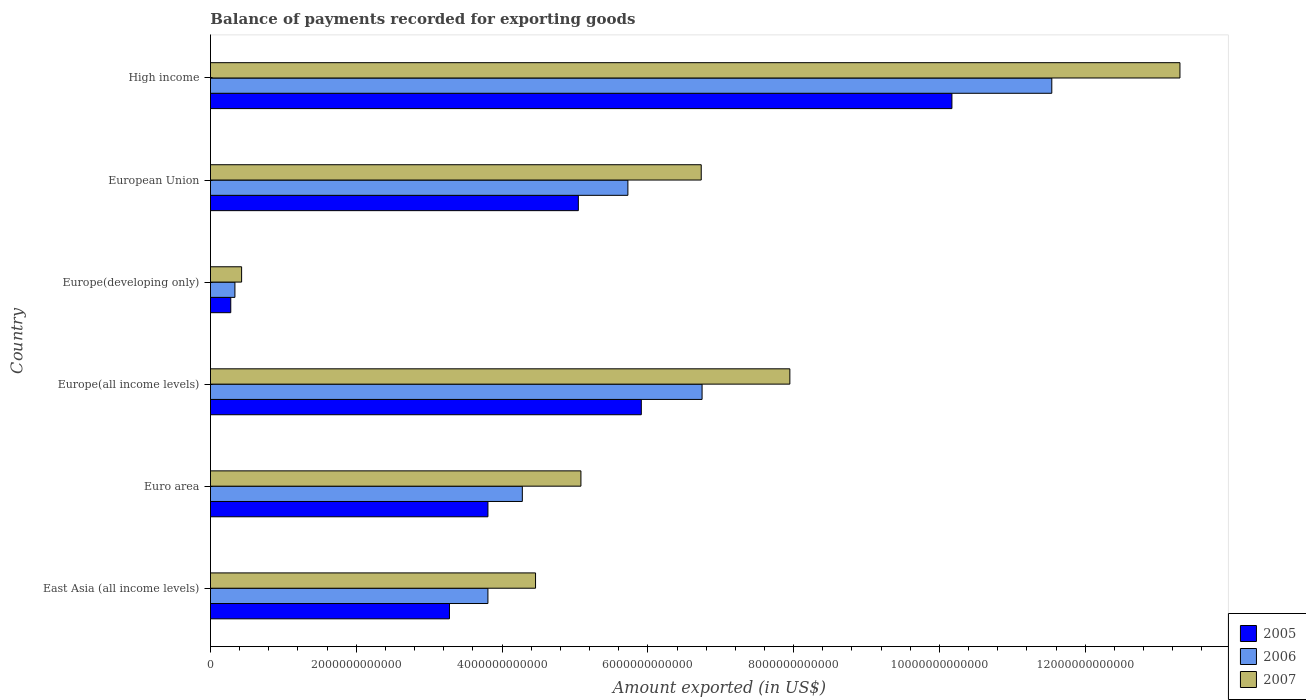How many different coloured bars are there?
Offer a very short reply. 3. How many groups of bars are there?
Ensure brevity in your answer.  6. Are the number of bars per tick equal to the number of legend labels?
Offer a very short reply. Yes. Are the number of bars on each tick of the Y-axis equal?
Give a very brief answer. Yes. How many bars are there on the 4th tick from the bottom?
Offer a very short reply. 3. What is the label of the 5th group of bars from the top?
Give a very brief answer. Euro area. What is the amount exported in 2005 in Europe(all income levels)?
Your answer should be very brief. 5.91e+12. Across all countries, what is the maximum amount exported in 2007?
Make the answer very short. 1.33e+13. Across all countries, what is the minimum amount exported in 2006?
Your response must be concise. 3.35e+11. In which country was the amount exported in 2005 minimum?
Give a very brief answer. Europe(developing only). What is the total amount exported in 2007 in the graph?
Your answer should be very brief. 3.79e+13. What is the difference between the amount exported in 2005 in Europe(all income levels) and that in Europe(developing only)?
Your response must be concise. 5.63e+12. What is the difference between the amount exported in 2005 in East Asia (all income levels) and the amount exported in 2006 in High income?
Keep it short and to the point. -8.26e+12. What is the average amount exported in 2005 per country?
Make the answer very short. 4.75e+12. What is the difference between the amount exported in 2005 and amount exported in 2006 in Euro area?
Make the answer very short. -4.72e+11. What is the ratio of the amount exported in 2006 in East Asia (all income levels) to that in Europe(all income levels)?
Offer a very short reply. 0.56. Is the amount exported in 2006 in Europe(developing only) less than that in European Union?
Provide a succinct answer. Yes. What is the difference between the highest and the second highest amount exported in 2006?
Keep it short and to the point. 4.80e+12. What is the difference between the highest and the lowest amount exported in 2007?
Offer a terse response. 1.29e+13. In how many countries, is the amount exported in 2005 greater than the average amount exported in 2005 taken over all countries?
Your answer should be very brief. 3. Is the sum of the amount exported in 2007 in East Asia (all income levels) and Europe(all income levels) greater than the maximum amount exported in 2006 across all countries?
Provide a short and direct response. Yes. What does the 1st bar from the top in Europe(developing only) represents?
Provide a succinct answer. 2007. What does the 1st bar from the bottom in Europe(all income levels) represents?
Offer a terse response. 2005. Is it the case that in every country, the sum of the amount exported in 2007 and amount exported in 2006 is greater than the amount exported in 2005?
Provide a short and direct response. Yes. How many bars are there?
Your answer should be compact. 18. What is the difference between two consecutive major ticks on the X-axis?
Keep it short and to the point. 2.00e+12. Are the values on the major ticks of X-axis written in scientific E-notation?
Offer a terse response. No. Does the graph contain any zero values?
Your answer should be compact. No. Does the graph contain grids?
Offer a very short reply. No. Where does the legend appear in the graph?
Your answer should be compact. Bottom right. How are the legend labels stacked?
Provide a short and direct response. Vertical. What is the title of the graph?
Offer a terse response. Balance of payments recorded for exporting goods. Does "2001" appear as one of the legend labels in the graph?
Your response must be concise. No. What is the label or title of the X-axis?
Your answer should be compact. Amount exported (in US$). What is the label or title of the Y-axis?
Keep it short and to the point. Country. What is the Amount exported (in US$) of 2005 in East Asia (all income levels)?
Your answer should be compact. 3.28e+12. What is the Amount exported (in US$) of 2006 in East Asia (all income levels)?
Offer a terse response. 3.81e+12. What is the Amount exported (in US$) of 2007 in East Asia (all income levels)?
Provide a succinct answer. 4.46e+12. What is the Amount exported (in US$) in 2005 in Euro area?
Provide a short and direct response. 3.81e+12. What is the Amount exported (in US$) of 2006 in Euro area?
Provide a short and direct response. 4.28e+12. What is the Amount exported (in US$) in 2007 in Euro area?
Provide a succinct answer. 5.08e+12. What is the Amount exported (in US$) of 2005 in Europe(all income levels)?
Give a very brief answer. 5.91e+12. What is the Amount exported (in US$) in 2006 in Europe(all income levels)?
Offer a very short reply. 6.74e+12. What is the Amount exported (in US$) in 2007 in Europe(all income levels)?
Your response must be concise. 7.95e+12. What is the Amount exported (in US$) in 2005 in Europe(developing only)?
Your answer should be compact. 2.78e+11. What is the Amount exported (in US$) of 2006 in Europe(developing only)?
Offer a terse response. 3.35e+11. What is the Amount exported (in US$) in 2007 in Europe(developing only)?
Offer a very short reply. 4.27e+11. What is the Amount exported (in US$) in 2005 in European Union?
Make the answer very short. 5.05e+12. What is the Amount exported (in US$) of 2006 in European Union?
Offer a terse response. 5.73e+12. What is the Amount exported (in US$) of 2007 in European Union?
Provide a succinct answer. 6.73e+12. What is the Amount exported (in US$) of 2005 in High income?
Your answer should be very brief. 1.02e+13. What is the Amount exported (in US$) of 2006 in High income?
Offer a terse response. 1.15e+13. What is the Amount exported (in US$) in 2007 in High income?
Your answer should be compact. 1.33e+13. Across all countries, what is the maximum Amount exported (in US$) of 2005?
Make the answer very short. 1.02e+13. Across all countries, what is the maximum Amount exported (in US$) in 2006?
Provide a short and direct response. 1.15e+13. Across all countries, what is the maximum Amount exported (in US$) of 2007?
Your answer should be compact. 1.33e+13. Across all countries, what is the minimum Amount exported (in US$) in 2005?
Give a very brief answer. 2.78e+11. Across all countries, what is the minimum Amount exported (in US$) in 2006?
Offer a terse response. 3.35e+11. Across all countries, what is the minimum Amount exported (in US$) of 2007?
Offer a terse response. 4.27e+11. What is the total Amount exported (in US$) of 2005 in the graph?
Your answer should be very brief. 2.85e+13. What is the total Amount exported (in US$) in 2006 in the graph?
Provide a succinct answer. 3.24e+13. What is the total Amount exported (in US$) in 2007 in the graph?
Provide a short and direct response. 3.79e+13. What is the difference between the Amount exported (in US$) in 2005 in East Asia (all income levels) and that in Euro area?
Provide a short and direct response. -5.28e+11. What is the difference between the Amount exported (in US$) of 2006 in East Asia (all income levels) and that in Euro area?
Offer a terse response. -4.72e+11. What is the difference between the Amount exported (in US$) in 2007 in East Asia (all income levels) and that in Euro area?
Keep it short and to the point. -6.22e+11. What is the difference between the Amount exported (in US$) of 2005 in East Asia (all income levels) and that in Europe(all income levels)?
Your answer should be very brief. -2.63e+12. What is the difference between the Amount exported (in US$) of 2006 in East Asia (all income levels) and that in Europe(all income levels)?
Provide a succinct answer. -2.94e+12. What is the difference between the Amount exported (in US$) in 2007 in East Asia (all income levels) and that in Europe(all income levels)?
Offer a very short reply. -3.49e+12. What is the difference between the Amount exported (in US$) in 2005 in East Asia (all income levels) and that in Europe(developing only)?
Provide a succinct answer. 3.00e+12. What is the difference between the Amount exported (in US$) of 2006 in East Asia (all income levels) and that in Europe(developing only)?
Provide a succinct answer. 3.47e+12. What is the difference between the Amount exported (in US$) in 2007 in East Asia (all income levels) and that in Europe(developing only)?
Offer a terse response. 4.03e+12. What is the difference between the Amount exported (in US$) in 2005 in East Asia (all income levels) and that in European Union?
Keep it short and to the point. -1.77e+12. What is the difference between the Amount exported (in US$) of 2006 in East Asia (all income levels) and that in European Union?
Provide a succinct answer. -1.92e+12. What is the difference between the Amount exported (in US$) in 2007 in East Asia (all income levels) and that in European Union?
Your response must be concise. -2.27e+12. What is the difference between the Amount exported (in US$) in 2005 in East Asia (all income levels) and that in High income?
Your answer should be very brief. -6.89e+12. What is the difference between the Amount exported (in US$) of 2006 in East Asia (all income levels) and that in High income?
Ensure brevity in your answer.  -7.74e+12. What is the difference between the Amount exported (in US$) in 2007 in East Asia (all income levels) and that in High income?
Provide a short and direct response. -8.84e+12. What is the difference between the Amount exported (in US$) in 2005 in Euro area and that in Europe(all income levels)?
Ensure brevity in your answer.  -2.10e+12. What is the difference between the Amount exported (in US$) in 2006 in Euro area and that in Europe(all income levels)?
Provide a short and direct response. -2.47e+12. What is the difference between the Amount exported (in US$) in 2007 in Euro area and that in Europe(all income levels)?
Offer a terse response. -2.87e+12. What is the difference between the Amount exported (in US$) of 2005 in Euro area and that in Europe(developing only)?
Your response must be concise. 3.53e+12. What is the difference between the Amount exported (in US$) of 2006 in Euro area and that in Europe(developing only)?
Ensure brevity in your answer.  3.94e+12. What is the difference between the Amount exported (in US$) in 2007 in Euro area and that in Europe(developing only)?
Ensure brevity in your answer.  4.65e+12. What is the difference between the Amount exported (in US$) in 2005 in Euro area and that in European Union?
Give a very brief answer. -1.24e+12. What is the difference between the Amount exported (in US$) in 2006 in Euro area and that in European Union?
Ensure brevity in your answer.  -1.45e+12. What is the difference between the Amount exported (in US$) in 2007 in Euro area and that in European Union?
Offer a very short reply. -1.65e+12. What is the difference between the Amount exported (in US$) of 2005 in Euro area and that in High income?
Ensure brevity in your answer.  -6.37e+12. What is the difference between the Amount exported (in US$) of 2006 in Euro area and that in High income?
Give a very brief answer. -7.26e+12. What is the difference between the Amount exported (in US$) in 2007 in Euro area and that in High income?
Your response must be concise. -8.22e+12. What is the difference between the Amount exported (in US$) of 2005 in Europe(all income levels) and that in Europe(developing only)?
Make the answer very short. 5.63e+12. What is the difference between the Amount exported (in US$) in 2006 in Europe(all income levels) and that in Europe(developing only)?
Your answer should be very brief. 6.41e+12. What is the difference between the Amount exported (in US$) of 2007 in Europe(all income levels) and that in Europe(developing only)?
Your response must be concise. 7.52e+12. What is the difference between the Amount exported (in US$) of 2005 in Europe(all income levels) and that in European Union?
Provide a short and direct response. 8.64e+11. What is the difference between the Amount exported (in US$) in 2006 in Europe(all income levels) and that in European Union?
Your answer should be compact. 1.02e+12. What is the difference between the Amount exported (in US$) in 2007 in Europe(all income levels) and that in European Union?
Offer a terse response. 1.22e+12. What is the difference between the Amount exported (in US$) in 2005 in Europe(all income levels) and that in High income?
Offer a terse response. -4.26e+12. What is the difference between the Amount exported (in US$) in 2006 in Europe(all income levels) and that in High income?
Provide a short and direct response. -4.80e+12. What is the difference between the Amount exported (in US$) in 2007 in Europe(all income levels) and that in High income?
Your response must be concise. -5.35e+12. What is the difference between the Amount exported (in US$) in 2005 in Europe(developing only) and that in European Union?
Make the answer very short. -4.77e+12. What is the difference between the Amount exported (in US$) of 2006 in Europe(developing only) and that in European Union?
Make the answer very short. -5.39e+12. What is the difference between the Amount exported (in US$) in 2007 in Europe(developing only) and that in European Union?
Your answer should be very brief. -6.31e+12. What is the difference between the Amount exported (in US$) in 2005 in Europe(developing only) and that in High income?
Provide a short and direct response. -9.89e+12. What is the difference between the Amount exported (in US$) in 2006 in Europe(developing only) and that in High income?
Ensure brevity in your answer.  -1.12e+13. What is the difference between the Amount exported (in US$) in 2007 in Europe(developing only) and that in High income?
Ensure brevity in your answer.  -1.29e+13. What is the difference between the Amount exported (in US$) of 2005 in European Union and that in High income?
Ensure brevity in your answer.  -5.13e+12. What is the difference between the Amount exported (in US$) of 2006 in European Union and that in High income?
Your response must be concise. -5.82e+12. What is the difference between the Amount exported (in US$) of 2007 in European Union and that in High income?
Ensure brevity in your answer.  -6.57e+12. What is the difference between the Amount exported (in US$) of 2005 in East Asia (all income levels) and the Amount exported (in US$) of 2006 in Euro area?
Keep it short and to the point. -1.00e+12. What is the difference between the Amount exported (in US$) of 2005 in East Asia (all income levels) and the Amount exported (in US$) of 2007 in Euro area?
Provide a succinct answer. -1.80e+12. What is the difference between the Amount exported (in US$) of 2006 in East Asia (all income levels) and the Amount exported (in US$) of 2007 in Euro area?
Give a very brief answer. -1.28e+12. What is the difference between the Amount exported (in US$) in 2005 in East Asia (all income levels) and the Amount exported (in US$) in 2006 in Europe(all income levels)?
Provide a short and direct response. -3.47e+12. What is the difference between the Amount exported (in US$) of 2005 in East Asia (all income levels) and the Amount exported (in US$) of 2007 in Europe(all income levels)?
Provide a succinct answer. -4.67e+12. What is the difference between the Amount exported (in US$) of 2006 in East Asia (all income levels) and the Amount exported (in US$) of 2007 in Europe(all income levels)?
Your response must be concise. -4.14e+12. What is the difference between the Amount exported (in US$) of 2005 in East Asia (all income levels) and the Amount exported (in US$) of 2006 in Europe(developing only)?
Provide a succinct answer. 2.94e+12. What is the difference between the Amount exported (in US$) of 2005 in East Asia (all income levels) and the Amount exported (in US$) of 2007 in Europe(developing only)?
Provide a short and direct response. 2.85e+12. What is the difference between the Amount exported (in US$) in 2006 in East Asia (all income levels) and the Amount exported (in US$) in 2007 in Europe(developing only)?
Make the answer very short. 3.38e+12. What is the difference between the Amount exported (in US$) in 2005 in East Asia (all income levels) and the Amount exported (in US$) in 2006 in European Union?
Make the answer very short. -2.45e+12. What is the difference between the Amount exported (in US$) in 2005 in East Asia (all income levels) and the Amount exported (in US$) in 2007 in European Union?
Give a very brief answer. -3.45e+12. What is the difference between the Amount exported (in US$) of 2006 in East Asia (all income levels) and the Amount exported (in US$) of 2007 in European Union?
Your response must be concise. -2.93e+12. What is the difference between the Amount exported (in US$) in 2005 in East Asia (all income levels) and the Amount exported (in US$) in 2006 in High income?
Your answer should be very brief. -8.26e+12. What is the difference between the Amount exported (in US$) of 2005 in East Asia (all income levels) and the Amount exported (in US$) of 2007 in High income?
Provide a succinct answer. -1.00e+13. What is the difference between the Amount exported (in US$) of 2006 in East Asia (all income levels) and the Amount exported (in US$) of 2007 in High income?
Provide a succinct answer. -9.49e+12. What is the difference between the Amount exported (in US$) in 2005 in Euro area and the Amount exported (in US$) in 2006 in Europe(all income levels)?
Your answer should be compact. -2.94e+12. What is the difference between the Amount exported (in US$) of 2005 in Euro area and the Amount exported (in US$) of 2007 in Europe(all income levels)?
Offer a terse response. -4.14e+12. What is the difference between the Amount exported (in US$) in 2006 in Euro area and the Amount exported (in US$) in 2007 in Europe(all income levels)?
Your answer should be compact. -3.67e+12. What is the difference between the Amount exported (in US$) in 2005 in Euro area and the Amount exported (in US$) in 2006 in Europe(developing only)?
Keep it short and to the point. 3.47e+12. What is the difference between the Amount exported (in US$) of 2005 in Euro area and the Amount exported (in US$) of 2007 in Europe(developing only)?
Offer a very short reply. 3.38e+12. What is the difference between the Amount exported (in US$) of 2006 in Euro area and the Amount exported (in US$) of 2007 in Europe(developing only)?
Provide a succinct answer. 3.85e+12. What is the difference between the Amount exported (in US$) in 2005 in Euro area and the Amount exported (in US$) in 2006 in European Union?
Your answer should be very brief. -1.92e+12. What is the difference between the Amount exported (in US$) in 2005 in Euro area and the Amount exported (in US$) in 2007 in European Union?
Ensure brevity in your answer.  -2.93e+12. What is the difference between the Amount exported (in US$) in 2006 in Euro area and the Amount exported (in US$) in 2007 in European Union?
Ensure brevity in your answer.  -2.45e+12. What is the difference between the Amount exported (in US$) of 2005 in Euro area and the Amount exported (in US$) of 2006 in High income?
Ensure brevity in your answer.  -7.74e+12. What is the difference between the Amount exported (in US$) of 2005 in Euro area and the Amount exported (in US$) of 2007 in High income?
Your answer should be very brief. -9.49e+12. What is the difference between the Amount exported (in US$) in 2006 in Euro area and the Amount exported (in US$) in 2007 in High income?
Keep it short and to the point. -9.02e+12. What is the difference between the Amount exported (in US$) of 2005 in Europe(all income levels) and the Amount exported (in US$) of 2006 in Europe(developing only)?
Provide a succinct answer. 5.58e+12. What is the difference between the Amount exported (in US$) in 2005 in Europe(all income levels) and the Amount exported (in US$) in 2007 in Europe(developing only)?
Your answer should be compact. 5.48e+12. What is the difference between the Amount exported (in US$) of 2006 in Europe(all income levels) and the Amount exported (in US$) of 2007 in Europe(developing only)?
Give a very brief answer. 6.32e+12. What is the difference between the Amount exported (in US$) of 2005 in Europe(all income levels) and the Amount exported (in US$) of 2006 in European Union?
Provide a short and direct response. 1.84e+11. What is the difference between the Amount exported (in US$) of 2005 in Europe(all income levels) and the Amount exported (in US$) of 2007 in European Union?
Provide a succinct answer. -8.22e+11. What is the difference between the Amount exported (in US$) of 2006 in Europe(all income levels) and the Amount exported (in US$) of 2007 in European Union?
Give a very brief answer. 1.16e+1. What is the difference between the Amount exported (in US$) of 2005 in Europe(all income levels) and the Amount exported (in US$) of 2006 in High income?
Your answer should be very brief. -5.63e+12. What is the difference between the Amount exported (in US$) in 2005 in Europe(all income levels) and the Amount exported (in US$) in 2007 in High income?
Your response must be concise. -7.39e+12. What is the difference between the Amount exported (in US$) of 2006 in Europe(all income levels) and the Amount exported (in US$) of 2007 in High income?
Offer a terse response. -6.56e+12. What is the difference between the Amount exported (in US$) in 2005 in Europe(developing only) and the Amount exported (in US$) in 2006 in European Union?
Your response must be concise. -5.45e+12. What is the difference between the Amount exported (in US$) in 2005 in Europe(developing only) and the Amount exported (in US$) in 2007 in European Union?
Your response must be concise. -6.45e+12. What is the difference between the Amount exported (in US$) in 2006 in Europe(developing only) and the Amount exported (in US$) in 2007 in European Union?
Your response must be concise. -6.40e+12. What is the difference between the Amount exported (in US$) in 2005 in Europe(developing only) and the Amount exported (in US$) in 2006 in High income?
Give a very brief answer. -1.13e+13. What is the difference between the Amount exported (in US$) in 2005 in Europe(developing only) and the Amount exported (in US$) in 2007 in High income?
Ensure brevity in your answer.  -1.30e+13. What is the difference between the Amount exported (in US$) in 2006 in Europe(developing only) and the Amount exported (in US$) in 2007 in High income?
Your answer should be compact. -1.30e+13. What is the difference between the Amount exported (in US$) of 2005 in European Union and the Amount exported (in US$) of 2006 in High income?
Offer a terse response. -6.50e+12. What is the difference between the Amount exported (in US$) of 2005 in European Union and the Amount exported (in US$) of 2007 in High income?
Ensure brevity in your answer.  -8.25e+12. What is the difference between the Amount exported (in US$) of 2006 in European Union and the Amount exported (in US$) of 2007 in High income?
Provide a short and direct response. -7.57e+12. What is the average Amount exported (in US$) in 2005 per country?
Make the answer very short. 4.75e+12. What is the average Amount exported (in US$) of 2006 per country?
Your answer should be very brief. 5.41e+12. What is the average Amount exported (in US$) of 2007 per country?
Ensure brevity in your answer.  6.32e+12. What is the difference between the Amount exported (in US$) in 2005 and Amount exported (in US$) in 2006 in East Asia (all income levels)?
Provide a succinct answer. -5.28e+11. What is the difference between the Amount exported (in US$) in 2005 and Amount exported (in US$) in 2007 in East Asia (all income levels)?
Provide a short and direct response. -1.18e+12. What is the difference between the Amount exported (in US$) of 2006 and Amount exported (in US$) of 2007 in East Asia (all income levels)?
Offer a very short reply. -6.53e+11. What is the difference between the Amount exported (in US$) of 2005 and Amount exported (in US$) of 2006 in Euro area?
Offer a terse response. -4.72e+11. What is the difference between the Amount exported (in US$) in 2005 and Amount exported (in US$) in 2007 in Euro area?
Your response must be concise. -1.28e+12. What is the difference between the Amount exported (in US$) in 2006 and Amount exported (in US$) in 2007 in Euro area?
Your response must be concise. -8.04e+11. What is the difference between the Amount exported (in US$) of 2005 and Amount exported (in US$) of 2006 in Europe(all income levels)?
Make the answer very short. -8.34e+11. What is the difference between the Amount exported (in US$) of 2005 and Amount exported (in US$) of 2007 in Europe(all income levels)?
Keep it short and to the point. -2.04e+12. What is the difference between the Amount exported (in US$) in 2006 and Amount exported (in US$) in 2007 in Europe(all income levels)?
Offer a very short reply. -1.20e+12. What is the difference between the Amount exported (in US$) of 2005 and Amount exported (in US$) of 2006 in Europe(developing only)?
Your response must be concise. -5.70e+1. What is the difference between the Amount exported (in US$) in 2005 and Amount exported (in US$) in 2007 in Europe(developing only)?
Provide a short and direct response. -1.49e+11. What is the difference between the Amount exported (in US$) in 2006 and Amount exported (in US$) in 2007 in Europe(developing only)?
Offer a terse response. -9.17e+1. What is the difference between the Amount exported (in US$) in 2005 and Amount exported (in US$) in 2006 in European Union?
Your answer should be very brief. -6.80e+11. What is the difference between the Amount exported (in US$) of 2005 and Amount exported (in US$) of 2007 in European Union?
Your answer should be compact. -1.69e+12. What is the difference between the Amount exported (in US$) in 2006 and Amount exported (in US$) in 2007 in European Union?
Your response must be concise. -1.01e+12. What is the difference between the Amount exported (in US$) of 2005 and Amount exported (in US$) of 2006 in High income?
Your answer should be very brief. -1.37e+12. What is the difference between the Amount exported (in US$) of 2005 and Amount exported (in US$) of 2007 in High income?
Your answer should be compact. -3.13e+12. What is the difference between the Amount exported (in US$) in 2006 and Amount exported (in US$) in 2007 in High income?
Ensure brevity in your answer.  -1.76e+12. What is the ratio of the Amount exported (in US$) of 2005 in East Asia (all income levels) to that in Euro area?
Your answer should be compact. 0.86. What is the ratio of the Amount exported (in US$) in 2006 in East Asia (all income levels) to that in Euro area?
Provide a short and direct response. 0.89. What is the ratio of the Amount exported (in US$) in 2007 in East Asia (all income levels) to that in Euro area?
Provide a short and direct response. 0.88. What is the ratio of the Amount exported (in US$) of 2005 in East Asia (all income levels) to that in Europe(all income levels)?
Your answer should be compact. 0.55. What is the ratio of the Amount exported (in US$) in 2006 in East Asia (all income levels) to that in Europe(all income levels)?
Offer a terse response. 0.56. What is the ratio of the Amount exported (in US$) in 2007 in East Asia (all income levels) to that in Europe(all income levels)?
Ensure brevity in your answer.  0.56. What is the ratio of the Amount exported (in US$) in 2005 in East Asia (all income levels) to that in Europe(developing only)?
Keep it short and to the point. 11.78. What is the ratio of the Amount exported (in US$) of 2006 in East Asia (all income levels) to that in Europe(developing only)?
Offer a very short reply. 11.35. What is the ratio of the Amount exported (in US$) of 2007 in East Asia (all income levels) to that in Europe(developing only)?
Provide a succinct answer. 10.44. What is the ratio of the Amount exported (in US$) in 2005 in East Asia (all income levels) to that in European Union?
Your response must be concise. 0.65. What is the ratio of the Amount exported (in US$) of 2006 in East Asia (all income levels) to that in European Union?
Keep it short and to the point. 0.66. What is the ratio of the Amount exported (in US$) in 2007 in East Asia (all income levels) to that in European Union?
Ensure brevity in your answer.  0.66. What is the ratio of the Amount exported (in US$) in 2005 in East Asia (all income levels) to that in High income?
Provide a succinct answer. 0.32. What is the ratio of the Amount exported (in US$) in 2006 in East Asia (all income levels) to that in High income?
Offer a terse response. 0.33. What is the ratio of the Amount exported (in US$) in 2007 in East Asia (all income levels) to that in High income?
Keep it short and to the point. 0.34. What is the ratio of the Amount exported (in US$) in 2005 in Euro area to that in Europe(all income levels)?
Keep it short and to the point. 0.64. What is the ratio of the Amount exported (in US$) in 2006 in Euro area to that in Europe(all income levels)?
Offer a terse response. 0.63. What is the ratio of the Amount exported (in US$) in 2007 in Euro area to that in Europe(all income levels)?
Offer a terse response. 0.64. What is the ratio of the Amount exported (in US$) of 2005 in Euro area to that in Europe(developing only)?
Make the answer very short. 13.67. What is the ratio of the Amount exported (in US$) of 2006 in Euro area to that in Europe(developing only)?
Provide a succinct answer. 12.76. What is the ratio of the Amount exported (in US$) of 2007 in Euro area to that in Europe(developing only)?
Offer a very short reply. 11.9. What is the ratio of the Amount exported (in US$) in 2005 in Euro area to that in European Union?
Give a very brief answer. 0.75. What is the ratio of the Amount exported (in US$) in 2006 in Euro area to that in European Union?
Provide a succinct answer. 0.75. What is the ratio of the Amount exported (in US$) of 2007 in Euro area to that in European Union?
Your answer should be compact. 0.75. What is the ratio of the Amount exported (in US$) in 2005 in Euro area to that in High income?
Provide a short and direct response. 0.37. What is the ratio of the Amount exported (in US$) of 2006 in Euro area to that in High income?
Your answer should be very brief. 0.37. What is the ratio of the Amount exported (in US$) of 2007 in Euro area to that in High income?
Provide a succinct answer. 0.38. What is the ratio of the Amount exported (in US$) of 2005 in Europe(all income levels) to that in Europe(developing only)?
Your answer should be very brief. 21.23. What is the ratio of the Amount exported (in US$) in 2006 in Europe(all income levels) to that in Europe(developing only)?
Provide a succinct answer. 20.11. What is the ratio of the Amount exported (in US$) in 2007 in Europe(all income levels) to that in Europe(developing only)?
Your answer should be very brief. 18.61. What is the ratio of the Amount exported (in US$) of 2005 in Europe(all income levels) to that in European Union?
Provide a succinct answer. 1.17. What is the ratio of the Amount exported (in US$) of 2006 in Europe(all income levels) to that in European Union?
Make the answer very short. 1.18. What is the ratio of the Amount exported (in US$) of 2007 in Europe(all income levels) to that in European Union?
Give a very brief answer. 1.18. What is the ratio of the Amount exported (in US$) in 2005 in Europe(all income levels) to that in High income?
Your response must be concise. 0.58. What is the ratio of the Amount exported (in US$) of 2006 in Europe(all income levels) to that in High income?
Ensure brevity in your answer.  0.58. What is the ratio of the Amount exported (in US$) in 2007 in Europe(all income levels) to that in High income?
Keep it short and to the point. 0.6. What is the ratio of the Amount exported (in US$) in 2005 in Europe(developing only) to that in European Union?
Provide a succinct answer. 0.06. What is the ratio of the Amount exported (in US$) of 2006 in Europe(developing only) to that in European Union?
Ensure brevity in your answer.  0.06. What is the ratio of the Amount exported (in US$) in 2007 in Europe(developing only) to that in European Union?
Offer a very short reply. 0.06. What is the ratio of the Amount exported (in US$) of 2005 in Europe(developing only) to that in High income?
Your response must be concise. 0.03. What is the ratio of the Amount exported (in US$) in 2006 in Europe(developing only) to that in High income?
Your answer should be compact. 0.03. What is the ratio of the Amount exported (in US$) in 2007 in Europe(developing only) to that in High income?
Your response must be concise. 0.03. What is the ratio of the Amount exported (in US$) of 2005 in European Union to that in High income?
Your answer should be very brief. 0.5. What is the ratio of the Amount exported (in US$) of 2006 in European Union to that in High income?
Ensure brevity in your answer.  0.5. What is the ratio of the Amount exported (in US$) of 2007 in European Union to that in High income?
Provide a succinct answer. 0.51. What is the difference between the highest and the second highest Amount exported (in US$) of 2005?
Provide a succinct answer. 4.26e+12. What is the difference between the highest and the second highest Amount exported (in US$) of 2006?
Ensure brevity in your answer.  4.80e+12. What is the difference between the highest and the second highest Amount exported (in US$) in 2007?
Ensure brevity in your answer.  5.35e+12. What is the difference between the highest and the lowest Amount exported (in US$) in 2005?
Keep it short and to the point. 9.89e+12. What is the difference between the highest and the lowest Amount exported (in US$) in 2006?
Provide a short and direct response. 1.12e+13. What is the difference between the highest and the lowest Amount exported (in US$) of 2007?
Your answer should be very brief. 1.29e+13. 